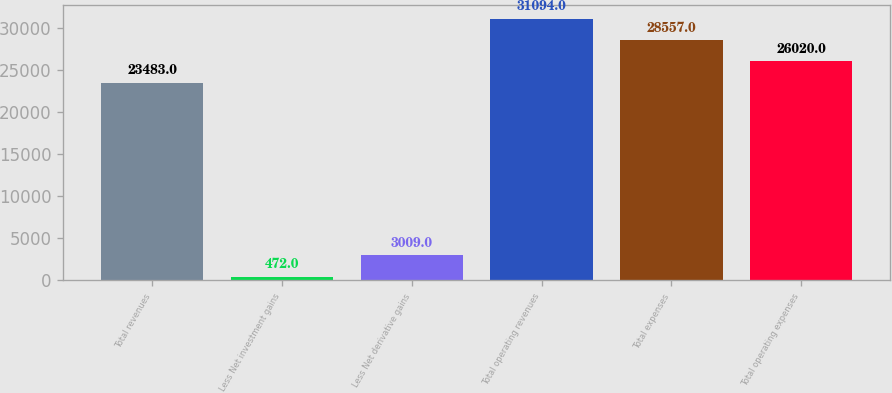Convert chart. <chart><loc_0><loc_0><loc_500><loc_500><bar_chart><fcel>Total revenues<fcel>Less Net investment gains<fcel>Less Net derivative gains<fcel>Total operating revenues<fcel>Total expenses<fcel>Total operating expenses<nl><fcel>23483<fcel>472<fcel>3009<fcel>31094<fcel>28557<fcel>26020<nl></chart> 